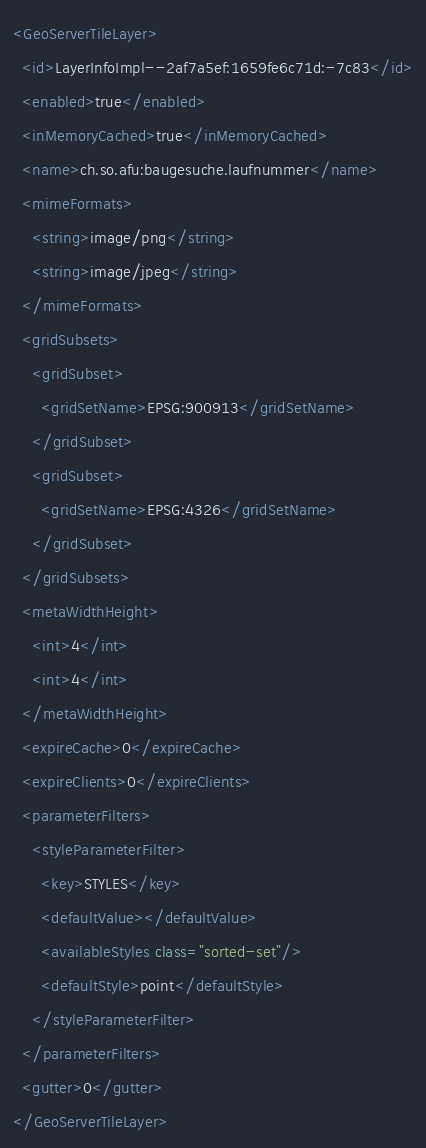<code> <loc_0><loc_0><loc_500><loc_500><_XML_><GeoServerTileLayer>
  <id>LayerInfoImpl--2af7a5ef:1659fe6c71d:-7c83</id>
  <enabled>true</enabled>
  <inMemoryCached>true</inMemoryCached>
  <name>ch.so.afu:baugesuche.laufnummer</name>
  <mimeFormats>
    <string>image/png</string>
    <string>image/jpeg</string>
  </mimeFormats>
  <gridSubsets>
    <gridSubset>
      <gridSetName>EPSG:900913</gridSetName>
    </gridSubset>
    <gridSubset>
      <gridSetName>EPSG:4326</gridSetName>
    </gridSubset>
  </gridSubsets>
  <metaWidthHeight>
    <int>4</int>
    <int>4</int>
  </metaWidthHeight>
  <expireCache>0</expireCache>
  <expireClients>0</expireClients>
  <parameterFilters>
    <styleParameterFilter>
      <key>STYLES</key>
      <defaultValue></defaultValue>
      <availableStyles class="sorted-set"/>
      <defaultStyle>point</defaultStyle>
    </styleParameterFilter>
  </parameterFilters>
  <gutter>0</gutter>
</GeoServerTileLayer></code> 